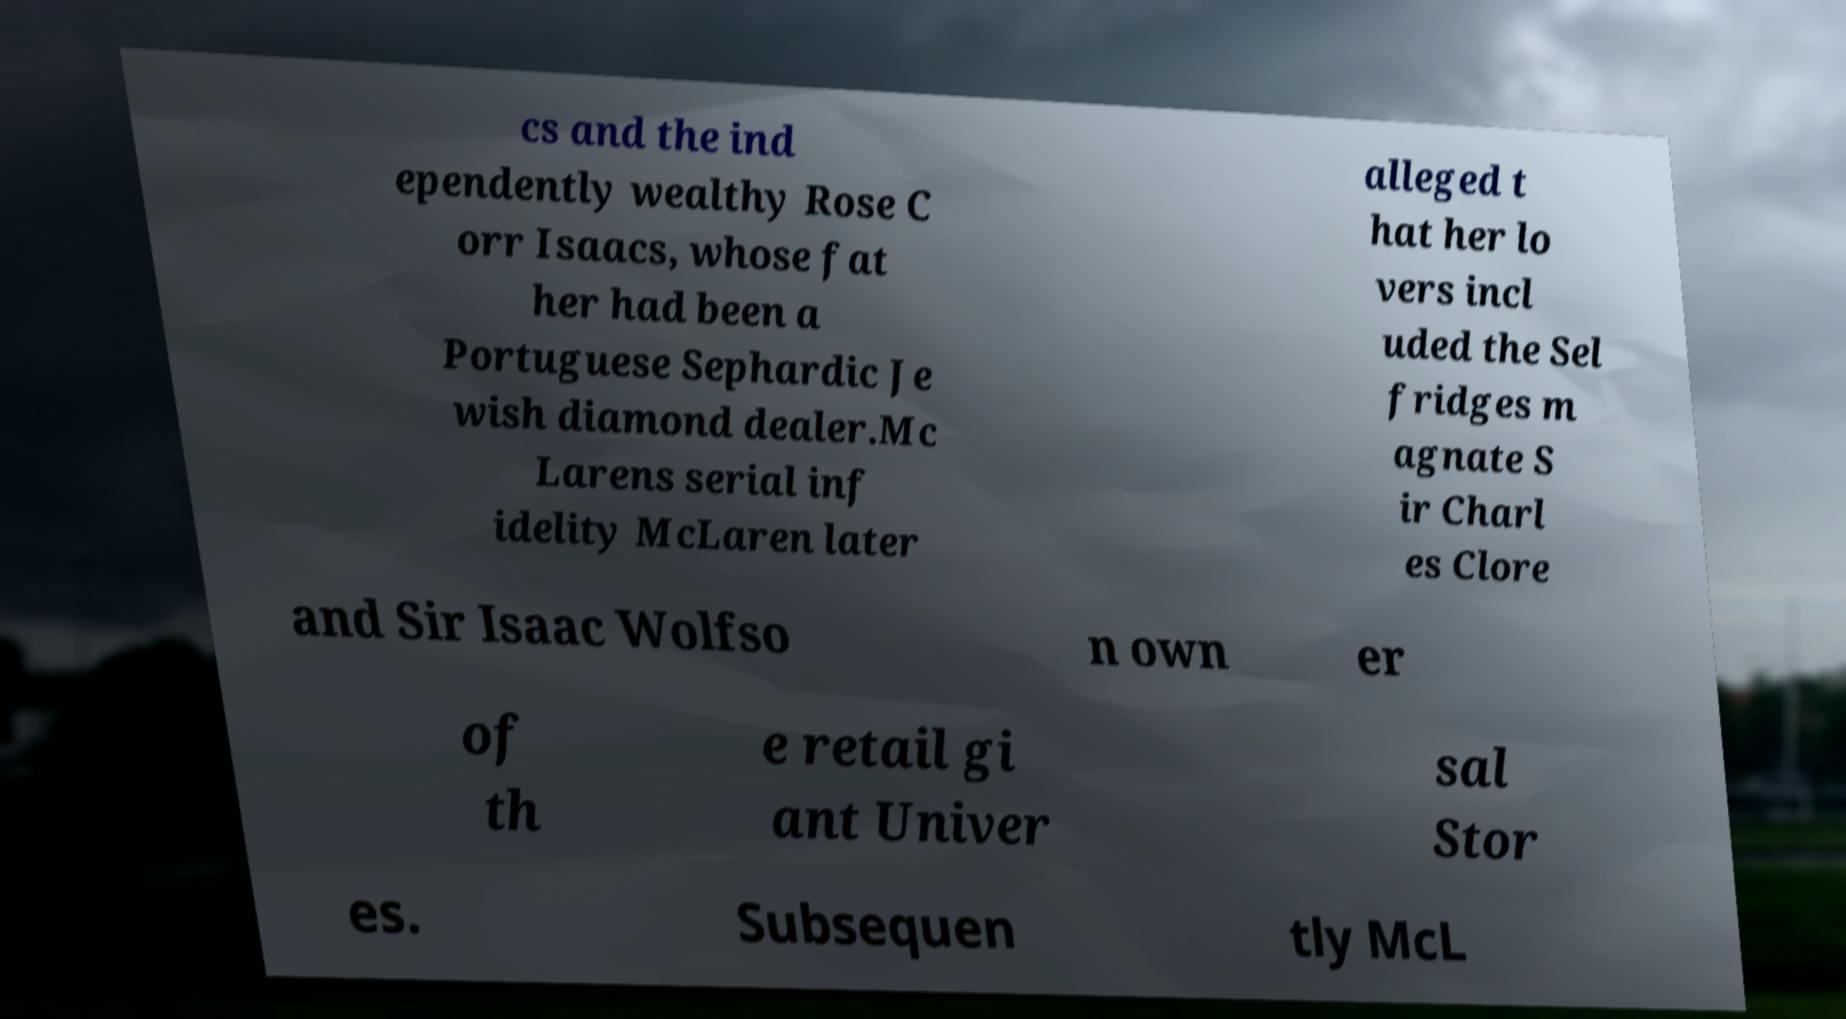Can you read and provide the text displayed in the image?This photo seems to have some interesting text. Can you extract and type it out for me? cs and the ind ependently wealthy Rose C orr Isaacs, whose fat her had been a Portuguese Sephardic Je wish diamond dealer.Mc Larens serial inf idelity McLaren later alleged t hat her lo vers incl uded the Sel fridges m agnate S ir Charl es Clore and Sir Isaac Wolfso n own er of th e retail gi ant Univer sal Stor es. Subsequen tly McL 